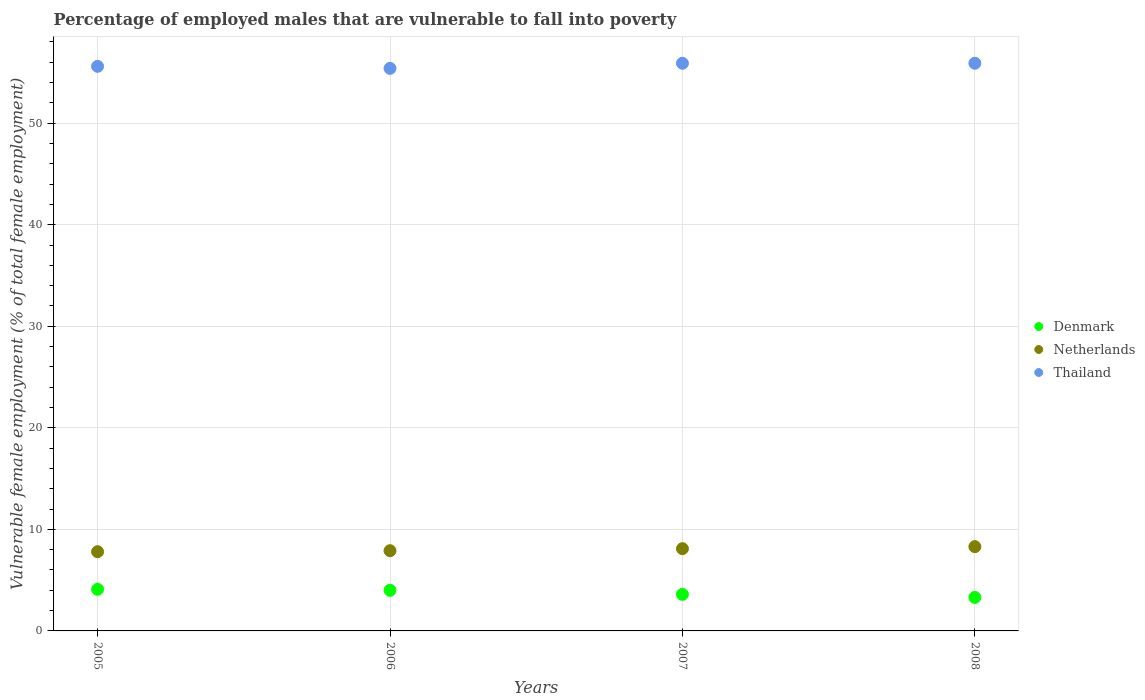How many different coloured dotlines are there?
Provide a short and direct response. 3. What is the percentage of employed males who are vulnerable to fall into poverty in Netherlands in 2006?
Your answer should be compact. 7.9. Across all years, what is the maximum percentage of employed males who are vulnerable to fall into poverty in Thailand?
Give a very brief answer. 55.9. Across all years, what is the minimum percentage of employed males who are vulnerable to fall into poverty in Netherlands?
Offer a very short reply. 7.8. In which year was the percentage of employed males who are vulnerable to fall into poverty in Thailand maximum?
Your answer should be compact. 2007. In which year was the percentage of employed males who are vulnerable to fall into poverty in Denmark minimum?
Offer a very short reply. 2008. What is the total percentage of employed males who are vulnerable to fall into poverty in Denmark in the graph?
Your answer should be very brief. 15. What is the difference between the percentage of employed males who are vulnerable to fall into poverty in Thailand in 2006 and that in 2008?
Ensure brevity in your answer.  -0.5. What is the difference between the percentage of employed males who are vulnerable to fall into poverty in Thailand in 2005 and the percentage of employed males who are vulnerable to fall into poverty in Netherlands in 2008?
Your response must be concise. 47.3. What is the average percentage of employed males who are vulnerable to fall into poverty in Thailand per year?
Give a very brief answer. 55.7. In the year 2008, what is the difference between the percentage of employed males who are vulnerable to fall into poverty in Thailand and percentage of employed males who are vulnerable to fall into poverty in Netherlands?
Make the answer very short. 47.6. In how many years, is the percentage of employed males who are vulnerable to fall into poverty in Netherlands greater than 2 %?
Provide a short and direct response. 4. What is the ratio of the percentage of employed males who are vulnerable to fall into poverty in Denmark in 2005 to that in 2008?
Your answer should be very brief. 1.24. What is the difference between the highest and the second highest percentage of employed males who are vulnerable to fall into poverty in Denmark?
Your answer should be very brief. 0.1. What is the difference between the highest and the lowest percentage of employed males who are vulnerable to fall into poverty in Netherlands?
Give a very brief answer. 0.5. In how many years, is the percentage of employed males who are vulnerable to fall into poverty in Netherlands greater than the average percentage of employed males who are vulnerable to fall into poverty in Netherlands taken over all years?
Offer a terse response. 2. Is it the case that in every year, the sum of the percentage of employed males who are vulnerable to fall into poverty in Denmark and percentage of employed males who are vulnerable to fall into poverty in Thailand  is greater than the percentage of employed males who are vulnerable to fall into poverty in Netherlands?
Keep it short and to the point. Yes. Does the percentage of employed males who are vulnerable to fall into poverty in Netherlands monotonically increase over the years?
Your answer should be compact. Yes. How many dotlines are there?
Keep it short and to the point. 3. How many years are there in the graph?
Your answer should be compact. 4. Are the values on the major ticks of Y-axis written in scientific E-notation?
Your answer should be compact. No. Does the graph contain any zero values?
Your answer should be very brief. No. Does the graph contain grids?
Ensure brevity in your answer.  Yes. What is the title of the graph?
Offer a terse response. Percentage of employed males that are vulnerable to fall into poverty. What is the label or title of the Y-axis?
Keep it short and to the point. Vulnerable female employment (% of total female employment). What is the Vulnerable female employment (% of total female employment) in Denmark in 2005?
Provide a short and direct response. 4.1. What is the Vulnerable female employment (% of total female employment) of Netherlands in 2005?
Provide a succinct answer. 7.8. What is the Vulnerable female employment (% of total female employment) of Thailand in 2005?
Ensure brevity in your answer.  55.6. What is the Vulnerable female employment (% of total female employment) of Netherlands in 2006?
Your answer should be very brief. 7.9. What is the Vulnerable female employment (% of total female employment) of Thailand in 2006?
Provide a short and direct response. 55.4. What is the Vulnerable female employment (% of total female employment) of Denmark in 2007?
Your answer should be compact. 3.6. What is the Vulnerable female employment (% of total female employment) of Netherlands in 2007?
Keep it short and to the point. 8.1. What is the Vulnerable female employment (% of total female employment) of Thailand in 2007?
Give a very brief answer. 55.9. What is the Vulnerable female employment (% of total female employment) in Denmark in 2008?
Keep it short and to the point. 3.3. What is the Vulnerable female employment (% of total female employment) in Netherlands in 2008?
Give a very brief answer. 8.3. What is the Vulnerable female employment (% of total female employment) of Thailand in 2008?
Provide a succinct answer. 55.9. Across all years, what is the maximum Vulnerable female employment (% of total female employment) of Denmark?
Your answer should be compact. 4.1. Across all years, what is the maximum Vulnerable female employment (% of total female employment) in Netherlands?
Make the answer very short. 8.3. Across all years, what is the maximum Vulnerable female employment (% of total female employment) in Thailand?
Provide a succinct answer. 55.9. Across all years, what is the minimum Vulnerable female employment (% of total female employment) in Denmark?
Provide a succinct answer. 3.3. Across all years, what is the minimum Vulnerable female employment (% of total female employment) in Netherlands?
Make the answer very short. 7.8. Across all years, what is the minimum Vulnerable female employment (% of total female employment) of Thailand?
Keep it short and to the point. 55.4. What is the total Vulnerable female employment (% of total female employment) in Netherlands in the graph?
Keep it short and to the point. 32.1. What is the total Vulnerable female employment (% of total female employment) in Thailand in the graph?
Ensure brevity in your answer.  222.8. What is the difference between the Vulnerable female employment (% of total female employment) in Netherlands in 2005 and that in 2006?
Provide a succinct answer. -0.1. What is the difference between the Vulnerable female employment (% of total female employment) of Denmark in 2005 and that in 2007?
Offer a terse response. 0.5. What is the difference between the Vulnerable female employment (% of total female employment) in Denmark in 2005 and that in 2008?
Ensure brevity in your answer.  0.8. What is the difference between the Vulnerable female employment (% of total female employment) in Thailand in 2005 and that in 2008?
Your answer should be very brief. -0.3. What is the difference between the Vulnerable female employment (% of total female employment) of Denmark in 2006 and that in 2007?
Keep it short and to the point. 0.4. What is the difference between the Vulnerable female employment (% of total female employment) in Netherlands in 2006 and that in 2007?
Offer a terse response. -0.2. What is the difference between the Vulnerable female employment (% of total female employment) in Netherlands in 2006 and that in 2008?
Provide a succinct answer. -0.4. What is the difference between the Vulnerable female employment (% of total female employment) of Denmark in 2007 and that in 2008?
Offer a very short reply. 0.3. What is the difference between the Vulnerable female employment (% of total female employment) in Netherlands in 2007 and that in 2008?
Ensure brevity in your answer.  -0.2. What is the difference between the Vulnerable female employment (% of total female employment) of Denmark in 2005 and the Vulnerable female employment (% of total female employment) of Netherlands in 2006?
Provide a short and direct response. -3.8. What is the difference between the Vulnerable female employment (% of total female employment) of Denmark in 2005 and the Vulnerable female employment (% of total female employment) of Thailand in 2006?
Your response must be concise. -51.3. What is the difference between the Vulnerable female employment (% of total female employment) in Netherlands in 2005 and the Vulnerable female employment (% of total female employment) in Thailand in 2006?
Your response must be concise. -47.6. What is the difference between the Vulnerable female employment (% of total female employment) in Denmark in 2005 and the Vulnerable female employment (% of total female employment) in Netherlands in 2007?
Ensure brevity in your answer.  -4. What is the difference between the Vulnerable female employment (% of total female employment) in Denmark in 2005 and the Vulnerable female employment (% of total female employment) in Thailand in 2007?
Your answer should be compact. -51.8. What is the difference between the Vulnerable female employment (% of total female employment) in Netherlands in 2005 and the Vulnerable female employment (% of total female employment) in Thailand in 2007?
Offer a very short reply. -48.1. What is the difference between the Vulnerable female employment (% of total female employment) in Denmark in 2005 and the Vulnerable female employment (% of total female employment) in Netherlands in 2008?
Give a very brief answer. -4.2. What is the difference between the Vulnerable female employment (% of total female employment) of Denmark in 2005 and the Vulnerable female employment (% of total female employment) of Thailand in 2008?
Ensure brevity in your answer.  -51.8. What is the difference between the Vulnerable female employment (% of total female employment) of Netherlands in 2005 and the Vulnerable female employment (% of total female employment) of Thailand in 2008?
Your response must be concise. -48.1. What is the difference between the Vulnerable female employment (% of total female employment) of Denmark in 2006 and the Vulnerable female employment (% of total female employment) of Thailand in 2007?
Make the answer very short. -51.9. What is the difference between the Vulnerable female employment (% of total female employment) of Netherlands in 2006 and the Vulnerable female employment (% of total female employment) of Thailand in 2007?
Ensure brevity in your answer.  -48. What is the difference between the Vulnerable female employment (% of total female employment) of Denmark in 2006 and the Vulnerable female employment (% of total female employment) of Thailand in 2008?
Your answer should be compact. -51.9. What is the difference between the Vulnerable female employment (% of total female employment) in Netherlands in 2006 and the Vulnerable female employment (% of total female employment) in Thailand in 2008?
Offer a very short reply. -48. What is the difference between the Vulnerable female employment (% of total female employment) of Denmark in 2007 and the Vulnerable female employment (% of total female employment) of Thailand in 2008?
Your response must be concise. -52.3. What is the difference between the Vulnerable female employment (% of total female employment) in Netherlands in 2007 and the Vulnerable female employment (% of total female employment) in Thailand in 2008?
Your answer should be very brief. -47.8. What is the average Vulnerable female employment (% of total female employment) in Denmark per year?
Provide a short and direct response. 3.75. What is the average Vulnerable female employment (% of total female employment) in Netherlands per year?
Give a very brief answer. 8.03. What is the average Vulnerable female employment (% of total female employment) in Thailand per year?
Your answer should be very brief. 55.7. In the year 2005, what is the difference between the Vulnerable female employment (% of total female employment) of Denmark and Vulnerable female employment (% of total female employment) of Netherlands?
Give a very brief answer. -3.7. In the year 2005, what is the difference between the Vulnerable female employment (% of total female employment) in Denmark and Vulnerable female employment (% of total female employment) in Thailand?
Give a very brief answer. -51.5. In the year 2005, what is the difference between the Vulnerable female employment (% of total female employment) in Netherlands and Vulnerable female employment (% of total female employment) in Thailand?
Offer a very short reply. -47.8. In the year 2006, what is the difference between the Vulnerable female employment (% of total female employment) in Denmark and Vulnerable female employment (% of total female employment) in Netherlands?
Keep it short and to the point. -3.9. In the year 2006, what is the difference between the Vulnerable female employment (% of total female employment) of Denmark and Vulnerable female employment (% of total female employment) of Thailand?
Provide a succinct answer. -51.4. In the year 2006, what is the difference between the Vulnerable female employment (% of total female employment) of Netherlands and Vulnerable female employment (% of total female employment) of Thailand?
Offer a terse response. -47.5. In the year 2007, what is the difference between the Vulnerable female employment (% of total female employment) in Denmark and Vulnerable female employment (% of total female employment) in Thailand?
Ensure brevity in your answer.  -52.3. In the year 2007, what is the difference between the Vulnerable female employment (% of total female employment) in Netherlands and Vulnerable female employment (% of total female employment) in Thailand?
Offer a terse response. -47.8. In the year 2008, what is the difference between the Vulnerable female employment (% of total female employment) of Denmark and Vulnerable female employment (% of total female employment) of Netherlands?
Your answer should be compact. -5. In the year 2008, what is the difference between the Vulnerable female employment (% of total female employment) in Denmark and Vulnerable female employment (% of total female employment) in Thailand?
Make the answer very short. -52.6. In the year 2008, what is the difference between the Vulnerable female employment (% of total female employment) in Netherlands and Vulnerable female employment (% of total female employment) in Thailand?
Offer a very short reply. -47.6. What is the ratio of the Vulnerable female employment (% of total female employment) of Netherlands in 2005 to that in 2006?
Offer a very short reply. 0.99. What is the ratio of the Vulnerable female employment (% of total female employment) of Thailand in 2005 to that in 2006?
Your response must be concise. 1. What is the ratio of the Vulnerable female employment (% of total female employment) of Denmark in 2005 to that in 2007?
Ensure brevity in your answer.  1.14. What is the ratio of the Vulnerable female employment (% of total female employment) in Thailand in 2005 to that in 2007?
Your answer should be compact. 0.99. What is the ratio of the Vulnerable female employment (% of total female employment) in Denmark in 2005 to that in 2008?
Provide a short and direct response. 1.24. What is the ratio of the Vulnerable female employment (% of total female employment) of Netherlands in 2005 to that in 2008?
Offer a very short reply. 0.94. What is the ratio of the Vulnerable female employment (% of total female employment) in Netherlands in 2006 to that in 2007?
Your answer should be very brief. 0.98. What is the ratio of the Vulnerable female employment (% of total female employment) in Thailand in 2006 to that in 2007?
Make the answer very short. 0.99. What is the ratio of the Vulnerable female employment (% of total female employment) in Denmark in 2006 to that in 2008?
Your answer should be very brief. 1.21. What is the ratio of the Vulnerable female employment (% of total female employment) of Netherlands in 2006 to that in 2008?
Provide a short and direct response. 0.95. What is the ratio of the Vulnerable female employment (% of total female employment) in Thailand in 2006 to that in 2008?
Your answer should be very brief. 0.99. What is the ratio of the Vulnerable female employment (% of total female employment) in Netherlands in 2007 to that in 2008?
Keep it short and to the point. 0.98. What is the ratio of the Vulnerable female employment (% of total female employment) in Thailand in 2007 to that in 2008?
Provide a succinct answer. 1. What is the difference between the highest and the second highest Vulnerable female employment (% of total female employment) of Netherlands?
Ensure brevity in your answer.  0.2. What is the difference between the highest and the second highest Vulnerable female employment (% of total female employment) in Thailand?
Your response must be concise. 0. What is the difference between the highest and the lowest Vulnerable female employment (% of total female employment) of Denmark?
Your answer should be very brief. 0.8. 